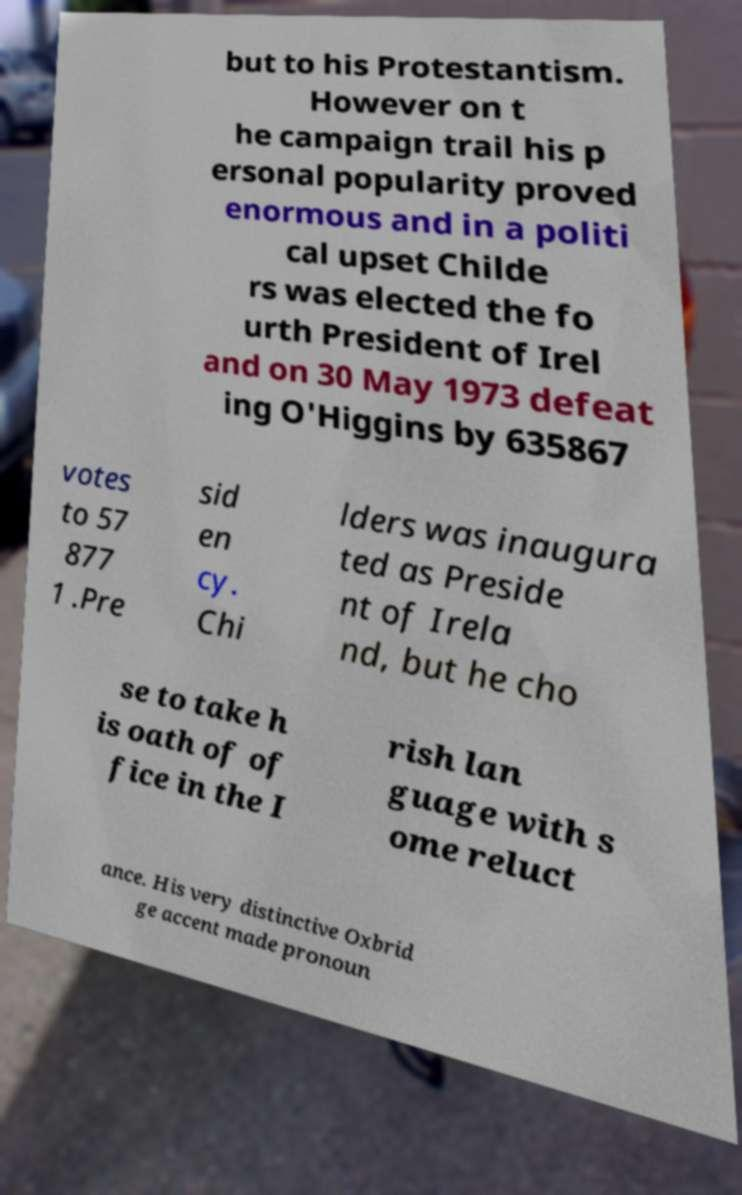I need the written content from this picture converted into text. Can you do that? but to his Protestantism. However on t he campaign trail his p ersonal popularity proved enormous and in a politi cal upset Childe rs was elected the fo urth President of Irel and on 30 May 1973 defeat ing O'Higgins by 635867 votes to 57 877 1 .Pre sid en cy. Chi lders was inaugura ted as Preside nt of Irela nd, but he cho se to take h is oath of of fice in the I rish lan guage with s ome reluct ance. His very distinctive Oxbrid ge accent made pronoun 